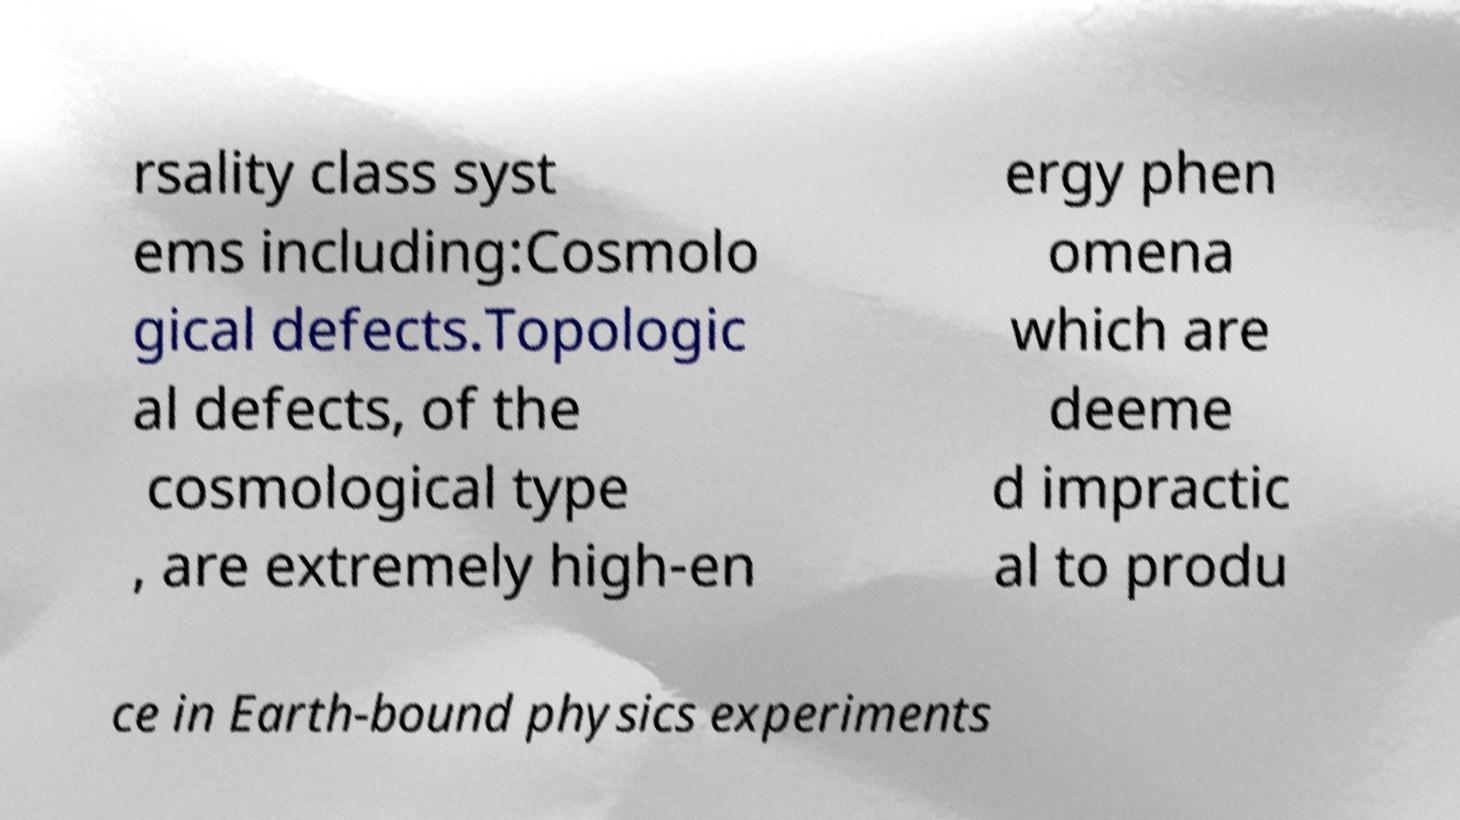Could you assist in decoding the text presented in this image and type it out clearly? rsality class syst ems including:Cosmolo gical defects.Topologic al defects, of the cosmological type , are extremely high-en ergy phen omena which are deeme d impractic al to produ ce in Earth-bound physics experiments 